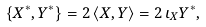Convert formula to latex. <formula><loc_0><loc_0><loc_500><loc_500>\{ X ^ { \ast } , Y ^ { \ast } \} = 2 \, \langle X , Y \rangle = 2 \, \iota _ { X } Y ^ { \ast } ,</formula> 